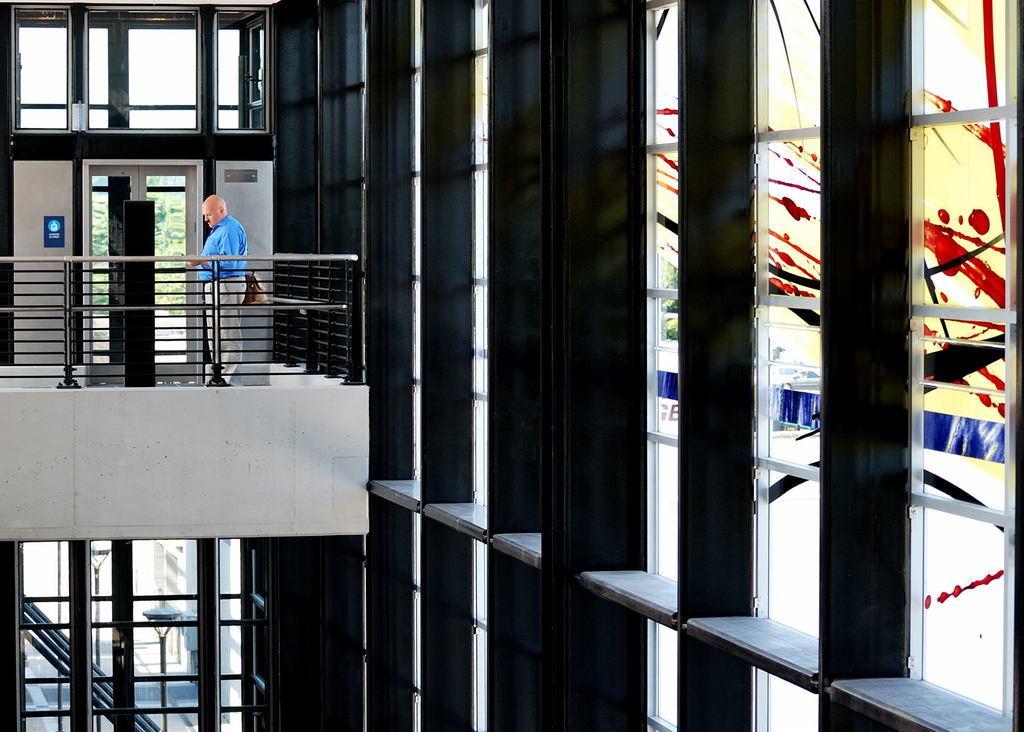In one or two sentences, can you explain what this image depicts? This image is taken from inside the building. In this image we can see there is a person standing in the balcony. 